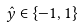Convert formula to latex. <formula><loc_0><loc_0><loc_500><loc_500>\hat { y } \in \{ - 1 , 1 \}</formula> 